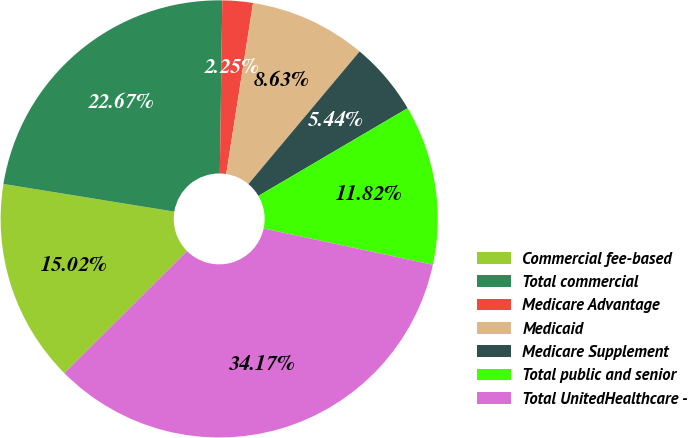<chart> <loc_0><loc_0><loc_500><loc_500><pie_chart><fcel>Commercial fee-based<fcel>Total commercial<fcel>Medicare Advantage<fcel>Medicaid<fcel>Medicare Supplement<fcel>Total public and senior<fcel>Total UnitedHealthcare -<nl><fcel>15.02%<fcel>22.67%<fcel>2.25%<fcel>8.63%<fcel>5.44%<fcel>11.82%<fcel>34.17%<nl></chart> 